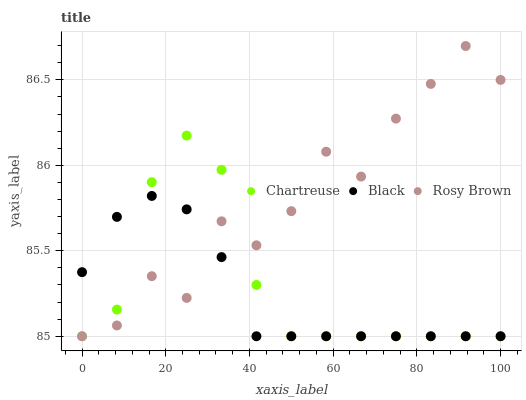Does Black have the minimum area under the curve?
Answer yes or no. Yes. Does Rosy Brown have the maximum area under the curve?
Answer yes or no. Yes. Does Rosy Brown have the minimum area under the curve?
Answer yes or no. No. Does Black have the maximum area under the curve?
Answer yes or no. No. Is Black the smoothest?
Answer yes or no. Yes. Is Rosy Brown the roughest?
Answer yes or no. Yes. Is Rosy Brown the smoothest?
Answer yes or no. No. Is Black the roughest?
Answer yes or no. No. Does Chartreuse have the lowest value?
Answer yes or no. Yes. Does Rosy Brown have the highest value?
Answer yes or no. Yes. Does Black have the highest value?
Answer yes or no. No. Does Chartreuse intersect Black?
Answer yes or no. Yes. Is Chartreuse less than Black?
Answer yes or no. No. Is Chartreuse greater than Black?
Answer yes or no. No. 